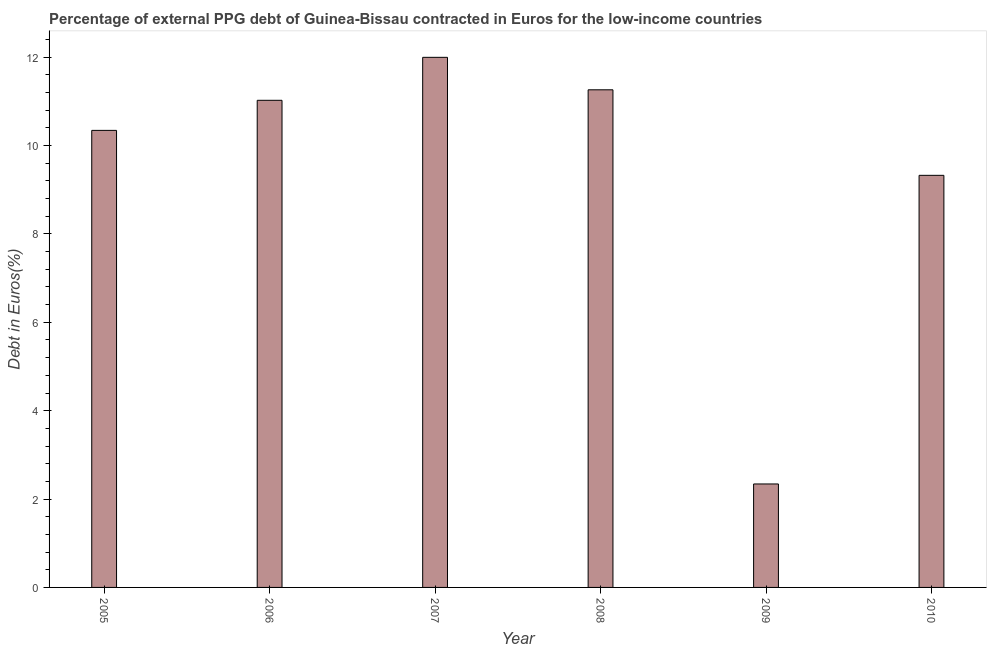Does the graph contain any zero values?
Your answer should be very brief. No. What is the title of the graph?
Keep it short and to the point. Percentage of external PPG debt of Guinea-Bissau contracted in Euros for the low-income countries. What is the label or title of the X-axis?
Your answer should be compact. Year. What is the label or title of the Y-axis?
Offer a terse response. Debt in Euros(%). What is the currency composition of ppg debt in 2010?
Make the answer very short. 9.33. Across all years, what is the maximum currency composition of ppg debt?
Give a very brief answer. 12. Across all years, what is the minimum currency composition of ppg debt?
Make the answer very short. 2.34. What is the sum of the currency composition of ppg debt?
Your answer should be very brief. 56.3. What is the average currency composition of ppg debt per year?
Ensure brevity in your answer.  9.38. What is the median currency composition of ppg debt?
Offer a terse response. 10.68. What is the ratio of the currency composition of ppg debt in 2005 to that in 2010?
Make the answer very short. 1.11. What is the difference between the highest and the second highest currency composition of ppg debt?
Give a very brief answer. 0.73. Is the sum of the currency composition of ppg debt in 2005 and 2008 greater than the maximum currency composition of ppg debt across all years?
Offer a terse response. Yes. What is the difference between the highest and the lowest currency composition of ppg debt?
Provide a short and direct response. 9.66. How many years are there in the graph?
Provide a short and direct response. 6. Are the values on the major ticks of Y-axis written in scientific E-notation?
Your answer should be compact. No. What is the Debt in Euros(%) in 2005?
Give a very brief answer. 10.34. What is the Debt in Euros(%) of 2006?
Your answer should be very brief. 11.02. What is the Debt in Euros(%) of 2007?
Offer a very short reply. 12. What is the Debt in Euros(%) of 2008?
Give a very brief answer. 11.26. What is the Debt in Euros(%) of 2009?
Offer a terse response. 2.34. What is the Debt in Euros(%) in 2010?
Your answer should be very brief. 9.33. What is the difference between the Debt in Euros(%) in 2005 and 2006?
Your response must be concise. -0.68. What is the difference between the Debt in Euros(%) in 2005 and 2007?
Provide a short and direct response. -1.65. What is the difference between the Debt in Euros(%) in 2005 and 2008?
Offer a very short reply. -0.92. What is the difference between the Debt in Euros(%) in 2005 and 2009?
Provide a succinct answer. 8. What is the difference between the Debt in Euros(%) in 2005 and 2010?
Ensure brevity in your answer.  1.02. What is the difference between the Debt in Euros(%) in 2006 and 2007?
Provide a short and direct response. -0.97. What is the difference between the Debt in Euros(%) in 2006 and 2008?
Offer a terse response. -0.24. What is the difference between the Debt in Euros(%) in 2006 and 2009?
Ensure brevity in your answer.  8.68. What is the difference between the Debt in Euros(%) in 2006 and 2010?
Provide a succinct answer. 1.7. What is the difference between the Debt in Euros(%) in 2007 and 2008?
Provide a short and direct response. 0.73. What is the difference between the Debt in Euros(%) in 2007 and 2009?
Your response must be concise. 9.66. What is the difference between the Debt in Euros(%) in 2007 and 2010?
Provide a short and direct response. 2.67. What is the difference between the Debt in Euros(%) in 2008 and 2009?
Your answer should be compact. 8.92. What is the difference between the Debt in Euros(%) in 2008 and 2010?
Offer a terse response. 1.94. What is the difference between the Debt in Euros(%) in 2009 and 2010?
Make the answer very short. -6.98. What is the ratio of the Debt in Euros(%) in 2005 to that in 2006?
Your answer should be compact. 0.94. What is the ratio of the Debt in Euros(%) in 2005 to that in 2007?
Provide a succinct answer. 0.86. What is the ratio of the Debt in Euros(%) in 2005 to that in 2008?
Your answer should be very brief. 0.92. What is the ratio of the Debt in Euros(%) in 2005 to that in 2009?
Ensure brevity in your answer.  4.42. What is the ratio of the Debt in Euros(%) in 2005 to that in 2010?
Give a very brief answer. 1.11. What is the ratio of the Debt in Euros(%) in 2006 to that in 2007?
Provide a short and direct response. 0.92. What is the ratio of the Debt in Euros(%) in 2006 to that in 2008?
Your answer should be compact. 0.98. What is the ratio of the Debt in Euros(%) in 2006 to that in 2009?
Ensure brevity in your answer.  4.71. What is the ratio of the Debt in Euros(%) in 2006 to that in 2010?
Keep it short and to the point. 1.18. What is the ratio of the Debt in Euros(%) in 2007 to that in 2008?
Keep it short and to the point. 1.06. What is the ratio of the Debt in Euros(%) in 2007 to that in 2009?
Your response must be concise. 5.12. What is the ratio of the Debt in Euros(%) in 2007 to that in 2010?
Offer a very short reply. 1.29. What is the ratio of the Debt in Euros(%) in 2008 to that in 2009?
Offer a very short reply. 4.81. What is the ratio of the Debt in Euros(%) in 2008 to that in 2010?
Ensure brevity in your answer.  1.21. What is the ratio of the Debt in Euros(%) in 2009 to that in 2010?
Your answer should be very brief. 0.25. 